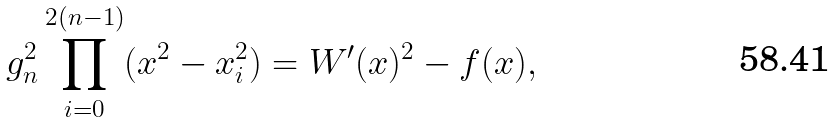<formula> <loc_0><loc_0><loc_500><loc_500>g _ { n } ^ { 2 } \prod _ { i = 0 } ^ { 2 ( n - 1 ) } ( x ^ { 2 } - x ^ { 2 } _ { i } ) = W ^ { \prime } ( x ) ^ { 2 } - f ( x ) ,</formula> 